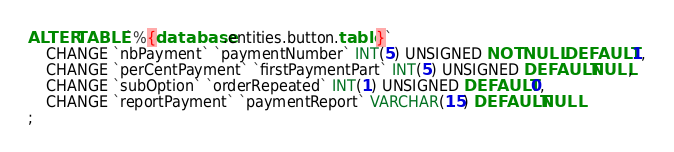Convert code to text. <code><loc_0><loc_0><loc_500><loc_500><_SQL_>ALTER TABLE `%{database.entities.button.table}`
    CHANGE `nbPayment` `paymentNumber` INT(5) UNSIGNED NOT NULL DEFAULT 1,
    CHANGE `perCentPayment` `firstPaymentPart` INT(5) UNSIGNED DEFAULT NULL,
    CHANGE `subOption` `orderRepeated` INT(1) UNSIGNED DEFAULT 0,
    CHANGE `reportPayment` `paymentReport` VARCHAR(15) DEFAULT NULL
;
</code> 